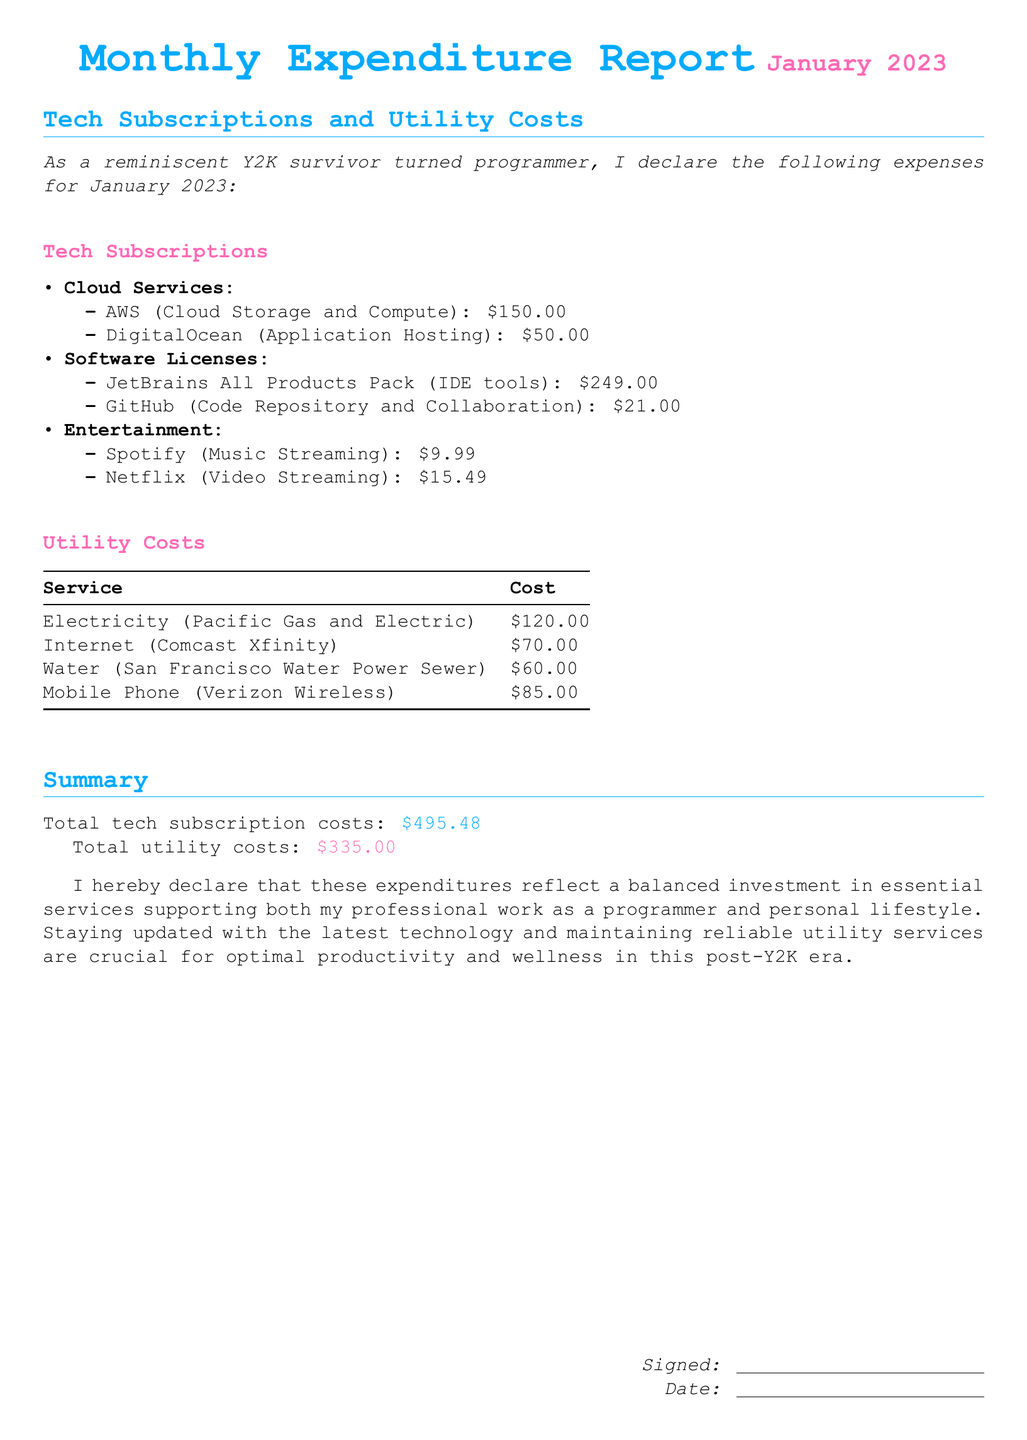What is the total cost of tech subscriptions? The total cost of tech subscriptions is clearly stated in the summary section of the document.
Answer: $495.48 How much does Spotify cost? The cost of Spotify is listed under the entertainment section of tech subscriptions.
Answer: $9.99 What is the utility cost for electricity? The utility cost for electricity is specified in the utility costs table.
Answer: $120.00 What is the cost of the JetBrains All Products Pack? The cost of the JetBrains All Products Pack is mentioned under the software licenses section of tech subscriptions.
Answer: $249.00 What service has the highest utility cost? To identify the service with the highest utility cost, we compare the figures provided for each service.
Answer: Electricity How many different tech subscription categories are listed? The document organizes tech subscriptions into specific categories, allowing us to count them easily.
Answer: 3 What date is the declaration for? The declaration specifically states the date in the title section of the document.
Answer: January 2023 What company provides the mobile phone service? The company providing the mobile phone service is mentioned in the utility costs table.
Answer: Verizon Wireless Who is the author of the declaration? The document concludes with a sign-off, indicating the author's identity.
Answer: Not provided 